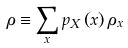<formula> <loc_0><loc_0><loc_500><loc_500>\rho \equiv \sum _ { x } p _ { X } \left ( x \right ) \rho _ { x }</formula> 